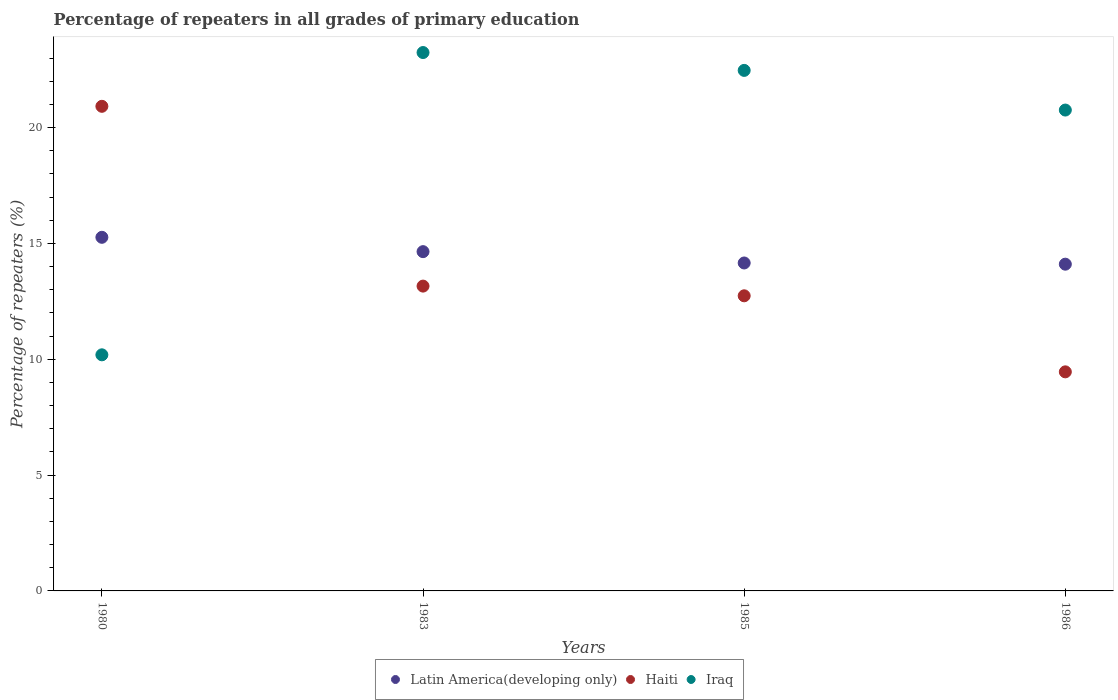How many different coloured dotlines are there?
Provide a short and direct response. 3. Is the number of dotlines equal to the number of legend labels?
Ensure brevity in your answer.  Yes. What is the percentage of repeaters in Iraq in 1985?
Provide a short and direct response. 22.47. Across all years, what is the maximum percentage of repeaters in Haiti?
Keep it short and to the point. 20.92. Across all years, what is the minimum percentage of repeaters in Iraq?
Make the answer very short. 10.19. In which year was the percentage of repeaters in Haiti maximum?
Provide a succinct answer. 1980. In which year was the percentage of repeaters in Haiti minimum?
Offer a very short reply. 1986. What is the total percentage of repeaters in Iraq in the graph?
Your response must be concise. 76.65. What is the difference between the percentage of repeaters in Iraq in 1985 and that in 1986?
Keep it short and to the point. 1.71. What is the difference between the percentage of repeaters in Latin America(developing only) in 1986 and the percentage of repeaters in Iraq in 1980?
Your response must be concise. 3.91. What is the average percentage of repeaters in Latin America(developing only) per year?
Your response must be concise. 14.54. In the year 1980, what is the difference between the percentage of repeaters in Latin America(developing only) and percentage of repeaters in Haiti?
Your answer should be compact. -5.65. In how many years, is the percentage of repeaters in Latin America(developing only) greater than 14 %?
Your answer should be very brief. 4. What is the ratio of the percentage of repeaters in Haiti in 1983 to that in 1986?
Offer a very short reply. 1.39. Is the percentage of repeaters in Iraq in 1980 less than that in 1986?
Keep it short and to the point. Yes. Is the difference between the percentage of repeaters in Latin America(developing only) in 1980 and 1983 greater than the difference between the percentage of repeaters in Haiti in 1980 and 1983?
Your answer should be compact. No. What is the difference between the highest and the second highest percentage of repeaters in Haiti?
Your response must be concise. 7.76. What is the difference between the highest and the lowest percentage of repeaters in Iraq?
Ensure brevity in your answer.  13.05. In how many years, is the percentage of repeaters in Haiti greater than the average percentage of repeaters in Haiti taken over all years?
Your answer should be compact. 1. Is the sum of the percentage of repeaters in Latin America(developing only) in 1985 and 1986 greater than the maximum percentage of repeaters in Iraq across all years?
Ensure brevity in your answer.  Yes. Does the percentage of repeaters in Latin America(developing only) monotonically increase over the years?
Give a very brief answer. No. Is the percentage of repeaters in Haiti strictly greater than the percentage of repeaters in Iraq over the years?
Make the answer very short. No. Is the percentage of repeaters in Haiti strictly less than the percentage of repeaters in Latin America(developing only) over the years?
Give a very brief answer. No. What is the difference between two consecutive major ticks on the Y-axis?
Provide a succinct answer. 5. Are the values on the major ticks of Y-axis written in scientific E-notation?
Ensure brevity in your answer.  No. Does the graph contain any zero values?
Keep it short and to the point. No. Does the graph contain grids?
Provide a short and direct response. No. How many legend labels are there?
Provide a succinct answer. 3. What is the title of the graph?
Ensure brevity in your answer.  Percentage of repeaters in all grades of primary education. Does "Colombia" appear as one of the legend labels in the graph?
Your response must be concise. No. What is the label or title of the Y-axis?
Provide a succinct answer. Percentage of repeaters (%). What is the Percentage of repeaters (%) of Latin America(developing only) in 1980?
Ensure brevity in your answer.  15.26. What is the Percentage of repeaters (%) in Haiti in 1980?
Your answer should be very brief. 20.92. What is the Percentage of repeaters (%) of Iraq in 1980?
Provide a short and direct response. 10.19. What is the Percentage of repeaters (%) in Latin America(developing only) in 1983?
Ensure brevity in your answer.  14.64. What is the Percentage of repeaters (%) in Haiti in 1983?
Provide a short and direct response. 13.16. What is the Percentage of repeaters (%) of Iraq in 1983?
Provide a short and direct response. 23.24. What is the Percentage of repeaters (%) of Latin America(developing only) in 1985?
Your response must be concise. 14.16. What is the Percentage of repeaters (%) in Haiti in 1985?
Your response must be concise. 12.74. What is the Percentage of repeaters (%) of Iraq in 1985?
Make the answer very short. 22.47. What is the Percentage of repeaters (%) in Latin America(developing only) in 1986?
Provide a succinct answer. 14.1. What is the Percentage of repeaters (%) of Haiti in 1986?
Provide a succinct answer. 9.46. What is the Percentage of repeaters (%) of Iraq in 1986?
Ensure brevity in your answer.  20.76. Across all years, what is the maximum Percentage of repeaters (%) in Latin America(developing only)?
Offer a terse response. 15.26. Across all years, what is the maximum Percentage of repeaters (%) of Haiti?
Give a very brief answer. 20.92. Across all years, what is the maximum Percentage of repeaters (%) of Iraq?
Your response must be concise. 23.24. Across all years, what is the minimum Percentage of repeaters (%) of Latin America(developing only)?
Keep it short and to the point. 14.1. Across all years, what is the minimum Percentage of repeaters (%) in Haiti?
Give a very brief answer. 9.46. Across all years, what is the minimum Percentage of repeaters (%) of Iraq?
Your answer should be compact. 10.19. What is the total Percentage of repeaters (%) in Latin America(developing only) in the graph?
Your answer should be very brief. 58.17. What is the total Percentage of repeaters (%) of Haiti in the graph?
Give a very brief answer. 56.27. What is the total Percentage of repeaters (%) of Iraq in the graph?
Give a very brief answer. 76.65. What is the difference between the Percentage of repeaters (%) in Latin America(developing only) in 1980 and that in 1983?
Give a very brief answer. 0.62. What is the difference between the Percentage of repeaters (%) of Haiti in 1980 and that in 1983?
Give a very brief answer. 7.76. What is the difference between the Percentage of repeaters (%) in Iraq in 1980 and that in 1983?
Keep it short and to the point. -13.05. What is the difference between the Percentage of repeaters (%) in Latin America(developing only) in 1980 and that in 1985?
Make the answer very short. 1.11. What is the difference between the Percentage of repeaters (%) of Haiti in 1980 and that in 1985?
Provide a succinct answer. 8.18. What is the difference between the Percentage of repeaters (%) in Iraq in 1980 and that in 1985?
Your answer should be compact. -12.28. What is the difference between the Percentage of repeaters (%) in Latin America(developing only) in 1980 and that in 1986?
Make the answer very short. 1.16. What is the difference between the Percentage of repeaters (%) in Haiti in 1980 and that in 1986?
Offer a very short reply. 11.46. What is the difference between the Percentage of repeaters (%) of Iraq in 1980 and that in 1986?
Make the answer very short. -10.56. What is the difference between the Percentage of repeaters (%) of Latin America(developing only) in 1983 and that in 1985?
Give a very brief answer. 0.49. What is the difference between the Percentage of repeaters (%) in Haiti in 1983 and that in 1985?
Provide a short and direct response. 0.42. What is the difference between the Percentage of repeaters (%) of Iraq in 1983 and that in 1985?
Your response must be concise. 0.77. What is the difference between the Percentage of repeaters (%) of Latin America(developing only) in 1983 and that in 1986?
Make the answer very short. 0.54. What is the difference between the Percentage of repeaters (%) of Haiti in 1983 and that in 1986?
Offer a very short reply. 3.7. What is the difference between the Percentage of repeaters (%) of Iraq in 1983 and that in 1986?
Your answer should be compact. 2.48. What is the difference between the Percentage of repeaters (%) in Latin America(developing only) in 1985 and that in 1986?
Offer a terse response. 0.05. What is the difference between the Percentage of repeaters (%) of Haiti in 1985 and that in 1986?
Keep it short and to the point. 3.28. What is the difference between the Percentage of repeaters (%) of Iraq in 1985 and that in 1986?
Make the answer very short. 1.71. What is the difference between the Percentage of repeaters (%) in Latin America(developing only) in 1980 and the Percentage of repeaters (%) in Haiti in 1983?
Ensure brevity in your answer.  2.11. What is the difference between the Percentage of repeaters (%) of Latin America(developing only) in 1980 and the Percentage of repeaters (%) of Iraq in 1983?
Your response must be concise. -7.97. What is the difference between the Percentage of repeaters (%) in Haiti in 1980 and the Percentage of repeaters (%) in Iraq in 1983?
Your answer should be compact. -2.32. What is the difference between the Percentage of repeaters (%) of Latin America(developing only) in 1980 and the Percentage of repeaters (%) of Haiti in 1985?
Ensure brevity in your answer.  2.52. What is the difference between the Percentage of repeaters (%) of Latin America(developing only) in 1980 and the Percentage of repeaters (%) of Iraq in 1985?
Your response must be concise. -7.2. What is the difference between the Percentage of repeaters (%) in Haiti in 1980 and the Percentage of repeaters (%) in Iraq in 1985?
Ensure brevity in your answer.  -1.55. What is the difference between the Percentage of repeaters (%) in Latin America(developing only) in 1980 and the Percentage of repeaters (%) in Haiti in 1986?
Your response must be concise. 5.81. What is the difference between the Percentage of repeaters (%) in Latin America(developing only) in 1980 and the Percentage of repeaters (%) in Iraq in 1986?
Provide a short and direct response. -5.49. What is the difference between the Percentage of repeaters (%) of Haiti in 1980 and the Percentage of repeaters (%) of Iraq in 1986?
Your response must be concise. 0.16. What is the difference between the Percentage of repeaters (%) in Latin America(developing only) in 1983 and the Percentage of repeaters (%) in Haiti in 1985?
Offer a terse response. 1.91. What is the difference between the Percentage of repeaters (%) of Latin America(developing only) in 1983 and the Percentage of repeaters (%) of Iraq in 1985?
Provide a short and direct response. -7.82. What is the difference between the Percentage of repeaters (%) in Haiti in 1983 and the Percentage of repeaters (%) in Iraq in 1985?
Your response must be concise. -9.31. What is the difference between the Percentage of repeaters (%) of Latin America(developing only) in 1983 and the Percentage of repeaters (%) of Haiti in 1986?
Provide a short and direct response. 5.19. What is the difference between the Percentage of repeaters (%) of Latin America(developing only) in 1983 and the Percentage of repeaters (%) of Iraq in 1986?
Offer a very short reply. -6.11. What is the difference between the Percentage of repeaters (%) in Haiti in 1983 and the Percentage of repeaters (%) in Iraq in 1986?
Keep it short and to the point. -7.6. What is the difference between the Percentage of repeaters (%) in Latin America(developing only) in 1985 and the Percentage of repeaters (%) in Haiti in 1986?
Give a very brief answer. 4.7. What is the difference between the Percentage of repeaters (%) of Latin America(developing only) in 1985 and the Percentage of repeaters (%) of Iraq in 1986?
Provide a short and direct response. -6.6. What is the difference between the Percentage of repeaters (%) in Haiti in 1985 and the Percentage of repeaters (%) in Iraq in 1986?
Your response must be concise. -8.02. What is the average Percentage of repeaters (%) of Latin America(developing only) per year?
Give a very brief answer. 14.54. What is the average Percentage of repeaters (%) in Haiti per year?
Give a very brief answer. 14.07. What is the average Percentage of repeaters (%) of Iraq per year?
Give a very brief answer. 19.16. In the year 1980, what is the difference between the Percentage of repeaters (%) in Latin America(developing only) and Percentage of repeaters (%) in Haiti?
Offer a very short reply. -5.65. In the year 1980, what is the difference between the Percentage of repeaters (%) in Latin America(developing only) and Percentage of repeaters (%) in Iraq?
Give a very brief answer. 5.07. In the year 1980, what is the difference between the Percentage of repeaters (%) in Haiti and Percentage of repeaters (%) in Iraq?
Keep it short and to the point. 10.73. In the year 1983, what is the difference between the Percentage of repeaters (%) in Latin America(developing only) and Percentage of repeaters (%) in Haiti?
Make the answer very short. 1.49. In the year 1983, what is the difference between the Percentage of repeaters (%) in Latin America(developing only) and Percentage of repeaters (%) in Iraq?
Provide a short and direct response. -8.59. In the year 1983, what is the difference between the Percentage of repeaters (%) of Haiti and Percentage of repeaters (%) of Iraq?
Offer a terse response. -10.08. In the year 1985, what is the difference between the Percentage of repeaters (%) of Latin America(developing only) and Percentage of repeaters (%) of Haiti?
Make the answer very short. 1.42. In the year 1985, what is the difference between the Percentage of repeaters (%) of Latin America(developing only) and Percentage of repeaters (%) of Iraq?
Offer a terse response. -8.31. In the year 1985, what is the difference between the Percentage of repeaters (%) of Haiti and Percentage of repeaters (%) of Iraq?
Your response must be concise. -9.73. In the year 1986, what is the difference between the Percentage of repeaters (%) in Latin America(developing only) and Percentage of repeaters (%) in Haiti?
Offer a very short reply. 4.65. In the year 1986, what is the difference between the Percentage of repeaters (%) in Latin America(developing only) and Percentage of repeaters (%) in Iraq?
Make the answer very short. -6.65. In the year 1986, what is the difference between the Percentage of repeaters (%) in Haiti and Percentage of repeaters (%) in Iraq?
Your answer should be very brief. -11.3. What is the ratio of the Percentage of repeaters (%) in Latin America(developing only) in 1980 to that in 1983?
Make the answer very short. 1.04. What is the ratio of the Percentage of repeaters (%) of Haiti in 1980 to that in 1983?
Provide a short and direct response. 1.59. What is the ratio of the Percentage of repeaters (%) of Iraq in 1980 to that in 1983?
Provide a succinct answer. 0.44. What is the ratio of the Percentage of repeaters (%) of Latin America(developing only) in 1980 to that in 1985?
Your answer should be compact. 1.08. What is the ratio of the Percentage of repeaters (%) in Haiti in 1980 to that in 1985?
Ensure brevity in your answer.  1.64. What is the ratio of the Percentage of repeaters (%) of Iraq in 1980 to that in 1985?
Make the answer very short. 0.45. What is the ratio of the Percentage of repeaters (%) of Latin America(developing only) in 1980 to that in 1986?
Offer a terse response. 1.08. What is the ratio of the Percentage of repeaters (%) of Haiti in 1980 to that in 1986?
Make the answer very short. 2.21. What is the ratio of the Percentage of repeaters (%) in Iraq in 1980 to that in 1986?
Provide a short and direct response. 0.49. What is the ratio of the Percentage of repeaters (%) of Latin America(developing only) in 1983 to that in 1985?
Provide a short and direct response. 1.03. What is the ratio of the Percentage of repeaters (%) in Haiti in 1983 to that in 1985?
Make the answer very short. 1.03. What is the ratio of the Percentage of repeaters (%) in Iraq in 1983 to that in 1985?
Give a very brief answer. 1.03. What is the ratio of the Percentage of repeaters (%) in Latin America(developing only) in 1983 to that in 1986?
Give a very brief answer. 1.04. What is the ratio of the Percentage of repeaters (%) in Haiti in 1983 to that in 1986?
Your answer should be very brief. 1.39. What is the ratio of the Percentage of repeaters (%) of Iraq in 1983 to that in 1986?
Provide a succinct answer. 1.12. What is the ratio of the Percentage of repeaters (%) in Haiti in 1985 to that in 1986?
Make the answer very short. 1.35. What is the ratio of the Percentage of repeaters (%) in Iraq in 1985 to that in 1986?
Your response must be concise. 1.08. What is the difference between the highest and the second highest Percentage of repeaters (%) in Latin America(developing only)?
Your response must be concise. 0.62. What is the difference between the highest and the second highest Percentage of repeaters (%) in Haiti?
Make the answer very short. 7.76. What is the difference between the highest and the second highest Percentage of repeaters (%) in Iraq?
Offer a terse response. 0.77. What is the difference between the highest and the lowest Percentage of repeaters (%) of Latin America(developing only)?
Keep it short and to the point. 1.16. What is the difference between the highest and the lowest Percentage of repeaters (%) of Haiti?
Provide a short and direct response. 11.46. What is the difference between the highest and the lowest Percentage of repeaters (%) of Iraq?
Keep it short and to the point. 13.05. 